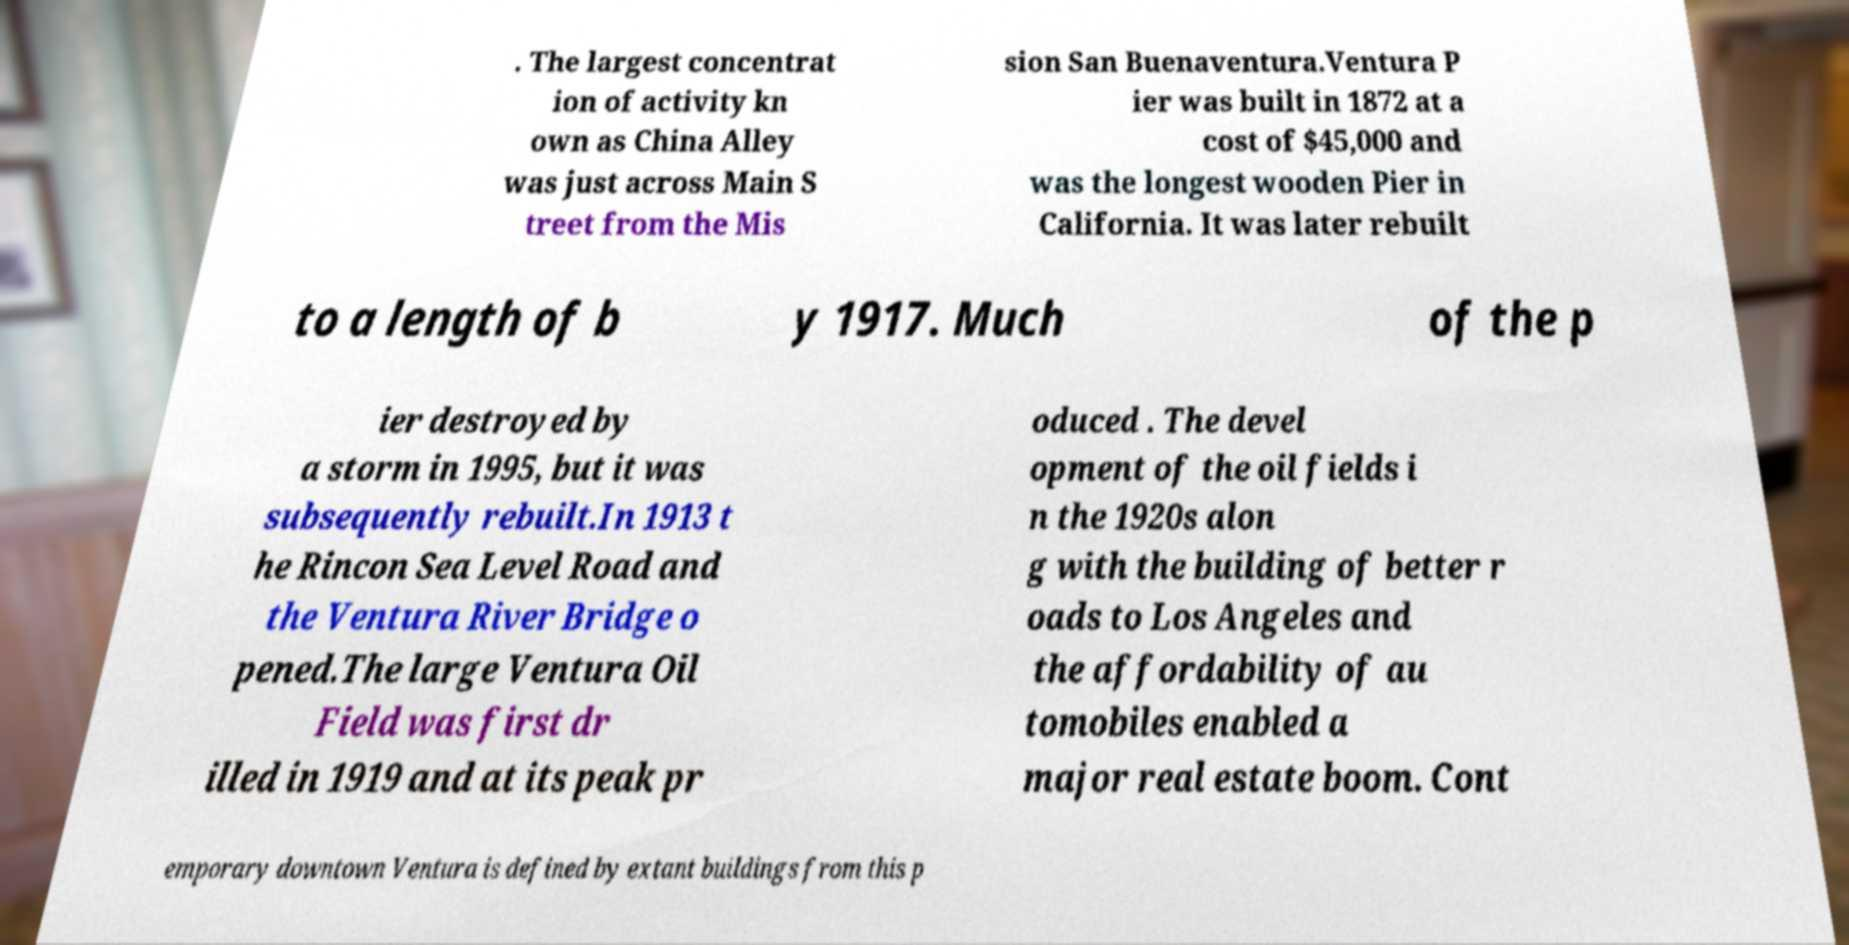There's text embedded in this image that I need extracted. Can you transcribe it verbatim? . The largest concentrat ion of activity kn own as China Alley was just across Main S treet from the Mis sion San Buenaventura.Ventura P ier was built in 1872 at a cost of $45,000 and was the longest wooden Pier in California. It was later rebuilt to a length of b y 1917. Much of the p ier destroyed by a storm in 1995, but it was subsequently rebuilt.In 1913 t he Rincon Sea Level Road and the Ventura River Bridge o pened.The large Ventura Oil Field was first dr illed in 1919 and at its peak pr oduced . The devel opment of the oil fields i n the 1920s alon g with the building of better r oads to Los Angeles and the affordability of au tomobiles enabled a major real estate boom. Cont emporary downtown Ventura is defined by extant buildings from this p 